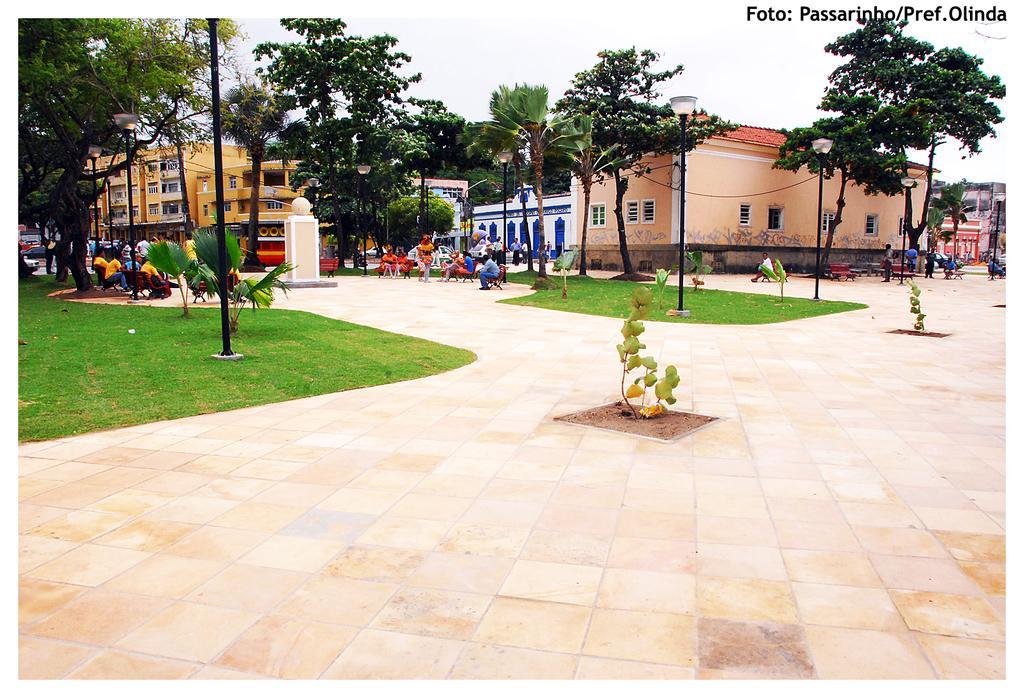How would you summarize this image in a sentence or two? In this image we can see the buildings, grass. We can see the plants and surrounding trees. In the middle we can see a pillar, we can see some people on the benches. We can see the lights and at the top we can see the sky. 